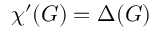<formula> <loc_0><loc_0><loc_500><loc_500>\chi ^ { \prime } ( G ) = \Delta ( G )</formula> 